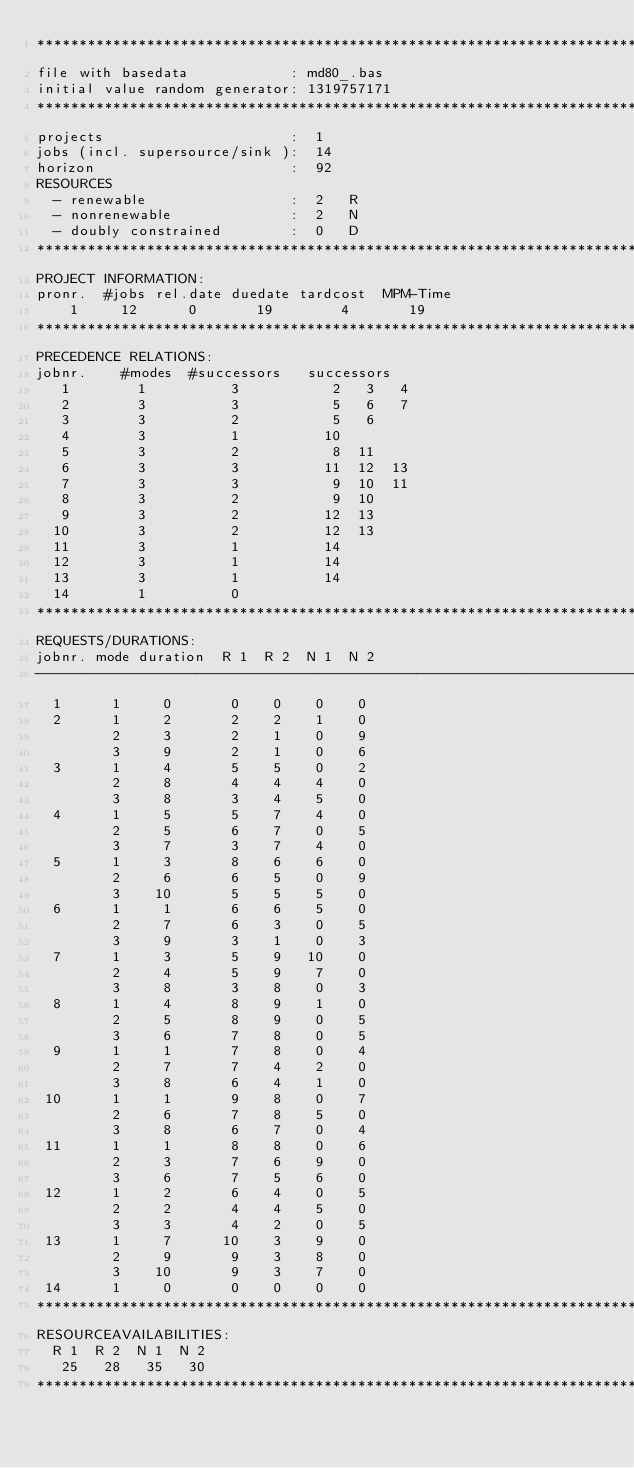Convert code to text. <code><loc_0><loc_0><loc_500><loc_500><_ObjectiveC_>************************************************************************
file with basedata            : md80_.bas
initial value random generator: 1319757171
************************************************************************
projects                      :  1
jobs (incl. supersource/sink ):  14
horizon                       :  92
RESOURCES
  - renewable                 :  2   R
  - nonrenewable              :  2   N
  - doubly constrained        :  0   D
************************************************************************
PROJECT INFORMATION:
pronr.  #jobs rel.date duedate tardcost  MPM-Time
    1     12      0       19        4       19
************************************************************************
PRECEDENCE RELATIONS:
jobnr.    #modes  #successors   successors
   1        1          3           2   3   4
   2        3          3           5   6   7
   3        3          2           5   6
   4        3          1          10
   5        3          2           8  11
   6        3          3          11  12  13
   7        3          3           9  10  11
   8        3          2           9  10
   9        3          2          12  13
  10        3          2          12  13
  11        3          1          14
  12        3          1          14
  13        3          1          14
  14        1          0        
************************************************************************
REQUESTS/DURATIONS:
jobnr. mode duration  R 1  R 2  N 1  N 2
------------------------------------------------------------------------
  1      1     0       0    0    0    0
  2      1     2       2    2    1    0
         2     3       2    1    0    9
         3     9       2    1    0    6
  3      1     4       5    5    0    2
         2     8       4    4    4    0
         3     8       3    4    5    0
  4      1     5       5    7    4    0
         2     5       6    7    0    5
         3     7       3    7    4    0
  5      1     3       8    6    6    0
         2     6       6    5    0    9
         3    10       5    5    5    0
  6      1     1       6    6    5    0
         2     7       6    3    0    5
         3     9       3    1    0    3
  7      1     3       5    9   10    0
         2     4       5    9    7    0
         3     8       3    8    0    3
  8      1     4       8    9    1    0
         2     5       8    9    0    5
         3     6       7    8    0    5
  9      1     1       7    8    0    4
         2     7       7    4    2    0
         3     8       6    4    1    0
 10      1     1       9    8    0    7
         2     6       7    8    5    0
         3     8       6    7    0    4
 11      1     1       8    8    0    6
         2     3       7    6    9    0
         3     6       7    5    6    0
 12      1     2       6    4    0    5
         2     2       4    4    5    0
         3     3       4    2    0    5
 13      1     7      10    3    9    0
         2     9       9    3    8    0
         3    10       9    3    7    0
 14      1     0       0    0    0    0
************************************************************************
RESOURCEAVAILABILITIES:
  R 1  R 2  N 1  N 2
   25   28   35   30
************************************************************************
</code> 